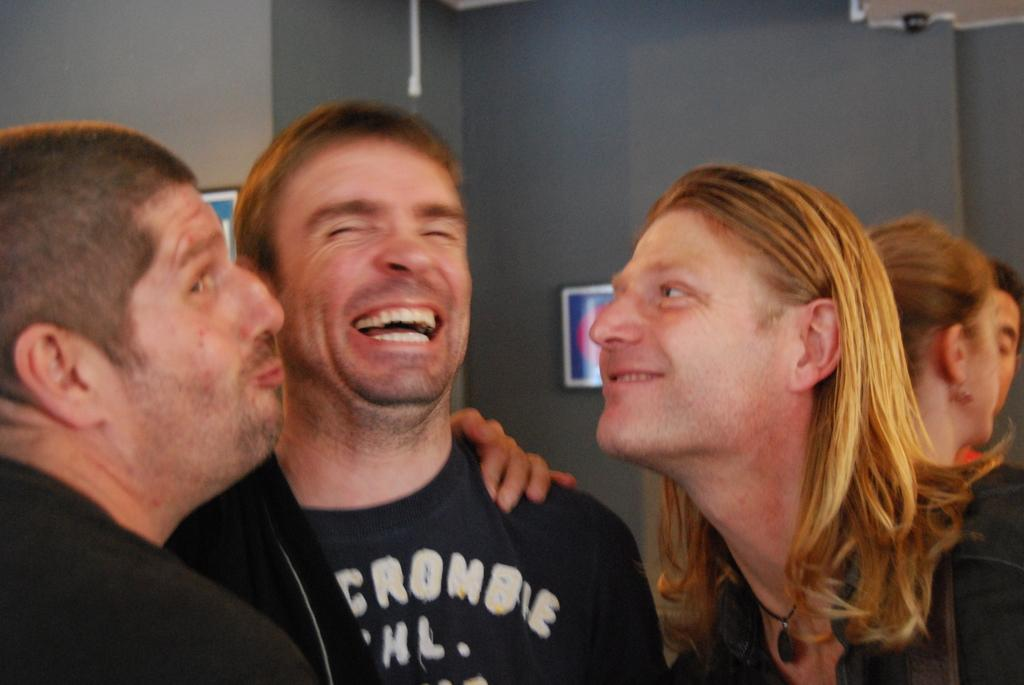What is happening in the image? There are people standing in the image. What can be seen in the background of the image? There is a wall in the background of the image. What is on the wall? There are two photos on the wall. What type of jewel is hanging from the wall in the image? There is no jewel hanging from the wall in the image; it only features two photos. 